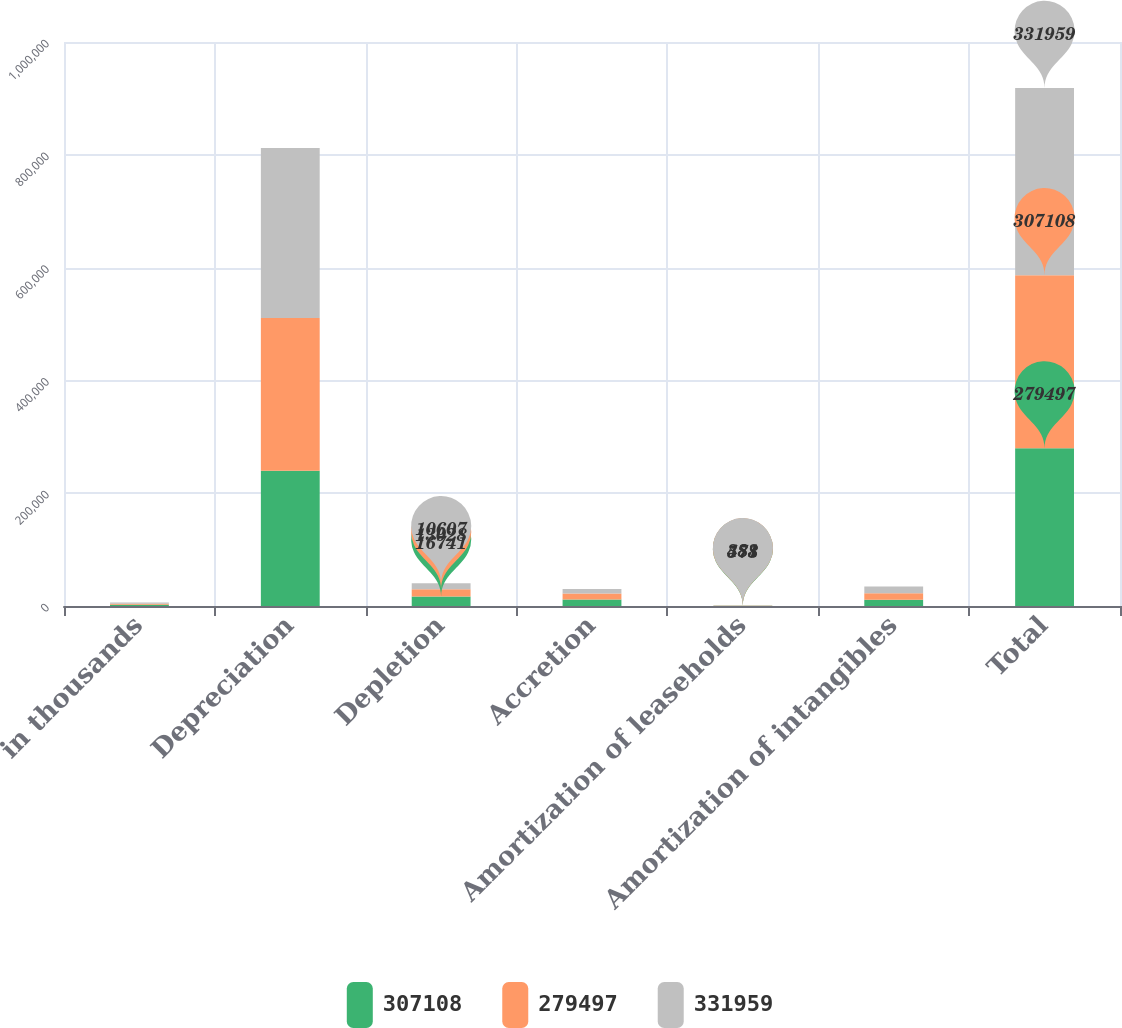<chart> <loc_0><loc_0><loc_500><loc_500><stacked_bar_chart><ecel><fcel>in thousands<fcel>Depreciation<fcel>Depletion<fcel>Accretion<fcel>Amortization of leaseholds<fcel>Amortization of intangibles<fcel>Total<nl><fcel>307108<fcel>2014<fcel>239611<fcel>16741<fcel>11601<fcel>578<fcel>10966<fcel>279497<nl><fcel>279497<fcel>2013<fcel>271180<fcel>13028<fcel>10685<fcel>483<fcel>11732<fcel>307108<nl><fcel>331959<fcel>2012<fcel>301146<fcel>10607<fcel>7956<fcel>381<fcel>11869<fcel>331959<nl></chart> 